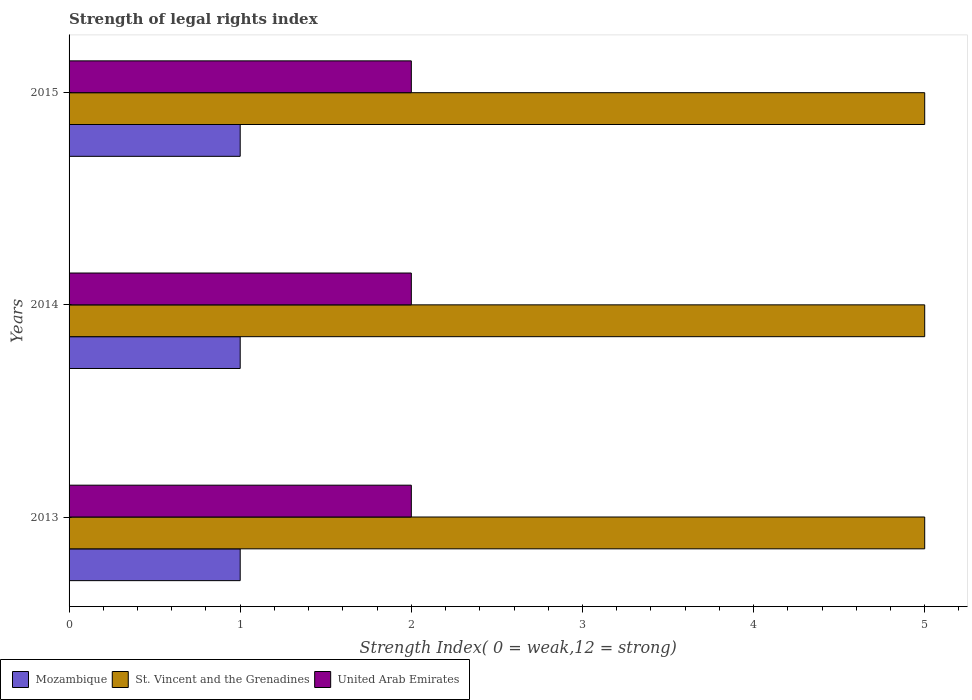How many different coloured bars are there?
Your answer should be very brief. 3. How many groups of bars are there?
Your answer should be very brief. 3. Are the number of bars per tick equal to the number of legend labels?
Your answer should be very brief. Yes. How many bars are there on the 3rd tick from the top?
Provide a succinct answer. 3. How many bars are there on the 2nd tick from the bottom?
Make the answer very short. 3. What is the strength index in United Arab Emirates in 2014?
Give a very brief answer. 2. Across all years, what is the maximum strength index in United Arab Emirates?
Make the answer very short. 2. Across all years, what is the minimum strength index in Mozambique?
Provide a succinct answer. 1. In which year was the strength index in St. Vincent and the Grenadines maximum?
Make the answer very short. 2013. In which year was the strength index in Mozambique minimum?
Provide a succinct answer. 2013. What is the total strength index in St. Vincent and the Grenadines in the graph?
Offer a terse response. 15. What is the difference between the strength index in Mozambique in 2014 and that in 2015?
Make the answer very short. 0. What is the difference between the strength index in United Arab Emirates in 2013 and the strength index in Mozambique in 2015?
Give a very brief answer. 1. What is the average strength index in Mozambique per year?
Offer a very short reply. 1. In the year 2014, what is the difference between the strength index in United Arab Emirates and strength index in Mozambique?
Make the answer very short. 1. In how many years, is the strength index in St. Vincent and the Grenadines greater than 1.8 ?
Provide a short and direct response. 3. What is the ratio of the strength index in Mozambique in 2013 to that in 2015?
Offer a terse response. 1. Is the difference between the strength index in United Arab Emirates in 2014 and 2015 greater than the difference between the strength index in Mozambique in 2014 and 2015?
Make the answer very short. No. What is the difference between the highest and the second highest strength index in Mozambique?
Your answer should be compact. 0. What is the difference between the highest and the lowest strength index in St. Vincent and the Grenadines?
Provide a short and direct response. 0. What does the 2nd bar from the top in 2015 represents?
Your response must be concise. St. Vincent and the Grenadines. What does the 2nd bar from the bottom in 2014 represents?
Your answer should be compact. St. Vincent and the Grenadines. Is it the case that in every year, the sum of the strength index in St. Vincent and the Grenadines and strength index in United Arab Emirates is greater than the strength index in Mozambique?
Offer a very short reply. Yes. Are all the bars in the graph horizontal?
Provide a succinct answer. Yes. How many years are there in the graph?
Offer a terse response. 3. Are the values on the major ticks of X-axis written in scientific E-notation?
Your answer should be compact. No. Does the graph contain any zero values?
Provide a short and direct response. No. Where does the legend appear in the graph?
Give a very brief answer. Bottom left. How many legend labels are there?
Offer a terse response. 3. How are the legend labels stacked?
Provide a short and direct response. Horizontal. What is the title of the graph?
Provide a succinct answer. Strength of legal rights index. What is the label or title of the X-axis?
Your answer should be very brief. Strength Index( 0 = weak,12 = strong). What is the label or title of the Y-axis?
Your answer should be very brief. Years. What is the Strength Index( 0 = weak,12 = strong) in St. Vincent and the Grenadines in 2013?
Offer a terse response. 5. What is the Strength Index( 0 = weak,12 = strong) in Mozambique in 2014?
Ensure brevity in your answer.  1. What is the Strength Index( 0 = weak,12 = strong) of St. Vincent and the Grenadines in 2014?
Provide a succinct answer. 5. What is the Strength Index( 0 = weak,12 = strong) in United Arab Emirates in 2014?
Keep it short and to the point. 2. Across all years, what is the maximum Strength Index( 0 = weak,12 = strong) of St. Vincent and the Grenadines?
Give a very brief answer. 5. Across all years, what is the minimum Strength Index( 0 = weak,12 = strong) in St. Vincent and the Grenadines?
Ensure brevity in your answer.  5. Across all years, what is the minimum Strength Index( 0 = weak,12 = strong) of United Arab Emirates?
Ensure brevity in your answer.  2. What is the total Strength Index( 0 = weak,12 = strong) of St. Vincent and the Grenadines in the graph?
Offer a very short reply. 15. What is the total Strength Index( 0 = weak,12 = strong) in United Arab Emirates in the graph?
Offer a terse response. 6. What is the difference between the Strength Index( 0 = weak,12 = strong) of St. Vincent and the Grenadines in 2013 and that in 2014?
Offer a terse response. 0. What is the difference between the Strength Index( 0 = weak,12 = strong) of United Arab Emirates in 2013 and that in 2014?
Ensure brevity in your answer.  0. What is the difference between the Strength Index( 0 = weak,12 = strong) of St. Vincent and the Grenadines in 2013 and that in 2015?
Ensure brevity in your answer.  0. What is the difference between the Strength Index( 0 = weak,12 = strong) in St. Vincent and the Grenadines in 2014 and that in 2015?
Your answer should be compact. 0. What is the difference between the Strength Index( 0 = weak,12 = strong) of Mozambique in 2013 and the Strength Index( 0 = weak,12 = strong) of St. Vincent and the Grenadines in 2014?
Your response must be concise. -4. What is the difference between the Strength Index( 0 = weak,12 = strong) in Mozambique in 2013 and the Strength Index( 0 = weak,12 = strong) in United Arab Emirates in 2014?
Your response must be concise. -1. What is the difference between the Strength Index( 0 = weak,12 = strong) in Mozambique in 2013 and the Strength Index( 0 = weak,12 = strong) in United Arab Emirates in 2015?
Make the answer very short. -1. What is the difference between the Strength Index( 0 = weak,12 = strong) of Mozambique in 2014 and the Strength Index( 0 = weak,12 = strong) of St. Vincent and the Grenadines in 2015?
Offer a very short reply. -4. What is the average Strength Index( 0 = weak,12 = strong) in St. Vincent and the Grenadines per year?
Give a very brief answer. 5. What is the average Strength Index( 0 = weak,12 = strong) in United Arab Emirates per year?
Your answer should be compact. 2. In the year 2014, what is the difference between the Strength Index( 0 = weak,12 = strong) in Mozambique and Strength Index( 0 = weak,12 = strong) in United Arab Emirates?
Offer a terse response. -1. In the year 2014, what is the difference between the Strength Index( 0 = weak,12 = strong) in St. Vincent and the Grenadines and Strength Index( 0 = weak,12 = strong) in United Arab Emirates?
Offer a terse response. 3. In the year 2015, what is the difference between the Strength Index( 0 = weak,12 = strong) of Mozambique and Strength Index( 0 = weak,12 = strong) of United Arab Emirates?
Provide a succinct answer. -1. What is the ratio of the Strength Index( 0 = weak,12 = strong) of United Arab Emirates in 2013 to that in 2014?
Your answer should be very brief. 1. What is the ratio of the Strength Index( 0 = weak,12 = strong) of United Arab Emirates in 2013 to that in 2015?
Give a very brief answer. 1. What is the ratio of the Strength Index( 0 = weak,12 = strong) in Mozambique in 2014 to that in 2015?
Offer a terse response. 1. What is the ratio of the Strength Index( 0 = weak,12 = strong) in St. Vincent and the Grenadines in 2014 to that in 2015?
Keep it short and to the point. 1. What is the ratio of the Strength Index( 0 = weak,12 = strong) of United Arab Emirates in 2014 to that in 2015?
Offer a terse response. 1. What is the difference between the highest and the second highest Strength Index( 0 = weak,12 = strong) in Mozambique?
Keep it short and to the point. 0. What is the difference between the highest and the second highest Strength Index( 0 = weak,12 = strong) in St. Vincent and the Grenadines?
Your answer should be compact. 0. What is the difference between the highest and the second highest Strength Index( 0 = weak,12 = strong) in United Arab Emirates?
Offer a terse response. 0. What is the difference between the highest and the lowest Strength Index( 0 = weak,12 = strong) of Mozambique?
Keep it short and to the point. 0. What is the difference between the highest and the lowest Strength Index( 0 = weak,12 = strong) of United Arab Emirates?
Your answer should be very brief. 0. 